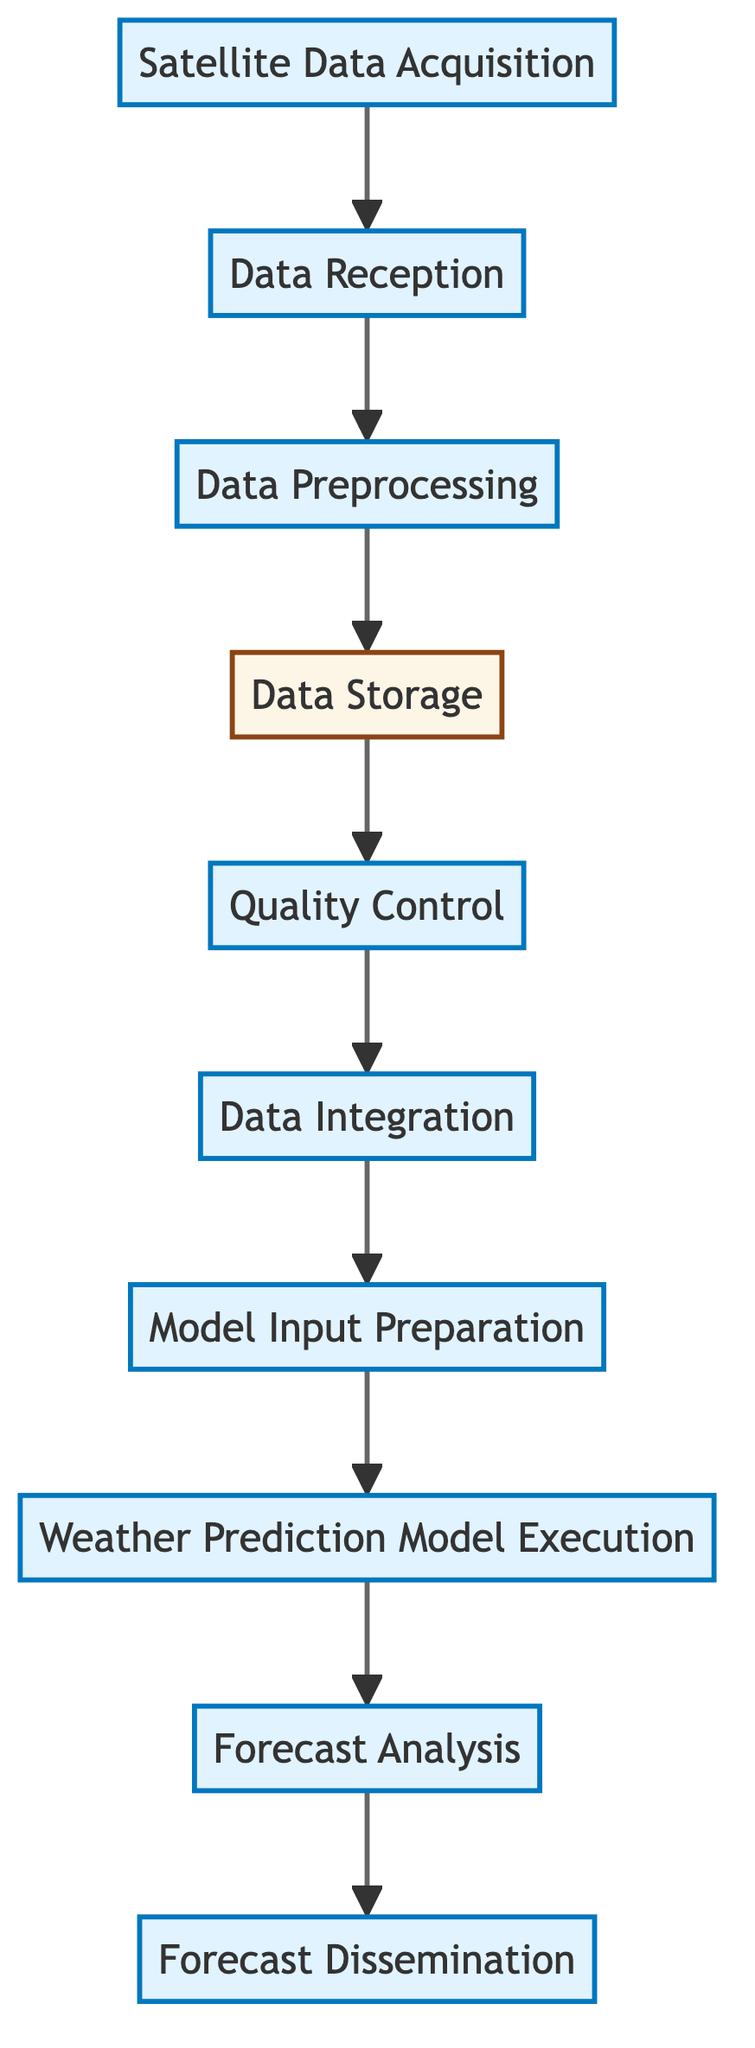What is the first step in the workflow? The first step is labeled "Satellite Data Acquisition," denoting the initial action taken in the workflow process.
Answer: Satellite Data Acquisition How many nodes are there in this diagram? The diagram contains ten distinct nodes, each representing a step in the satellite data processing workflow.
Answer: 10 What does the "Data Integration" step follow? The "Data Integration" step (F) follows after the "Quality Control" step (E) as visible in the flowchart, showing the sequential progression of the workflow.
Answer: Quality Control Which step is responsible for running weather prediction models? The step responsible for running weather prediction models is labeled "Weather Prediction Model Execution," indicating its function in the workflow.
Answer: Weather Prediction Model Execution What step comes before "Forecast Analysis"? The step that comes before "Forecast Analysis" is "Weather Prediction Model Execution," indicating the order of operations in the diagram.
Answer: Weather Prediction Model Execution Identify the function of the "Data Storage" step. The "Data Storage" step serves the function of storing preprocessed data in databases for easy retrieval and management.
Answer: Store preprocessed data Which tool might be used in the "Data Preprocessing" step? The tools mentioned for use in the "Data Preprocessing" step include SMOS and MODIS, which are relevant for processing satellite data.
Answer: SMOS and MODIS What is the final step in the workflow? The final step in the workflow is labeled "Forecast Dissemination," indicating the last action taken to distribute forecasts to users.
Answer: Forecast Dissemination What comes after the "Model Input Preparation" step? The step that comes after "Model Input Preparation" is "Weather Prediction Model Execution," representing the next phase of the process.
Answer: Weather Prediction Model Execution 